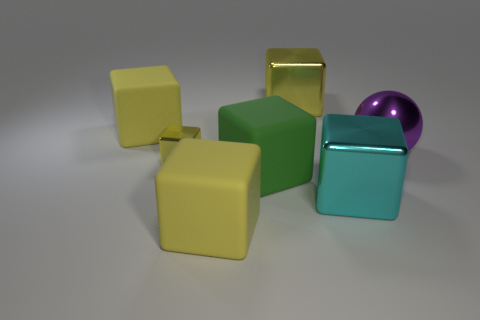Are there any other things that are the same size as the sphere?
Provide a succinct answer. Yes. Is there a small block that has the same color as the metallic ball?
Give a very brief answer. No. Are there more purple spheres that are on the left side of the big green rubber cube than rubber things?
Your answer should be compact. No. Does the tiny thing have the same shape as the big metallic thing that is in front of the big purple shiny sphere?
Your answer should be compact. Yes. Are there any small cubes?
Your response must be concise. Yes. What number of large objects are either purple rubber cylinders or green blocks?
Provide a short and direct response. 1. Are there more yellow metal objects that are behind the large sphere than yellow cubes that are to the left of the big yellow metal cube?
Keep it short and to the point. No. Is the large sphere made of the same material as the green object in front of the ball?
Offer a terse response. No. What color is the small shiny cube?
Your answer should be very brief. Yellow. There is a big yellow matte object behind the big green rubber thing; what is its shape?
Your response must be concise. Cube. 